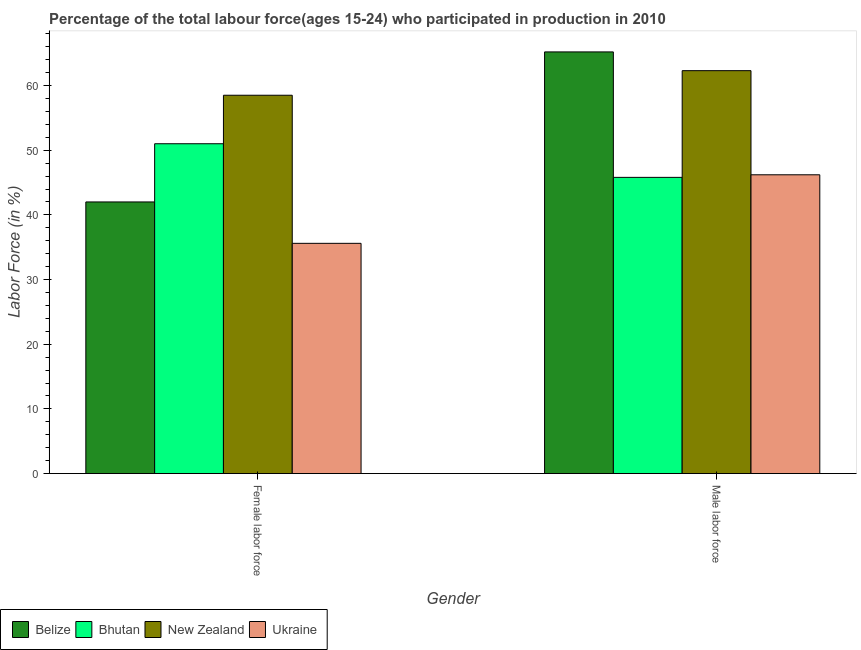How many different coloured bars are there?
Ensure brevity in your answer.  4. Are the number of bars on each tick of the X-axis equal?
Give a very brief answer. Yes. How many bars are there on the 1st tick from the left?
Ensure brevity in your answer.  4. How many bars are there on the 2nd tick from the right?
Keep it short and to the point. 4. What is the label of the 2nd group of bars from the left?
Make the answer very short. Male labor force. What is the percentage of male labour force in New Zealand?
Your response must be concise. 62.3. Across all countries, what is the maximum percentage of male labour force?
Your answer should be compact. 65.2. Across all countries, what is the minimum percentage of male labour force?
Offer a terse response. 45.8. In which country was the percentage of male labour force maximum?
Your answer should be compact. Belize. In which country was the percentage of male labour force minimum?
Provide a short and direct response. Bhutan. What is the total percentage of female labor force in the graph?
Your answer should be very brief. 187.1. What is the difference between the percentage of male labour force in Belize and that in New Zealand?
Offer a very short reply. 2.9. What is the difference between the percentage of male labour force in Bhutan and the percentage of female labor force in New Zealand?
Offer a terse response. -12.7. What is the average percentage of female labor force per country?
Offer a terse response. 46.77. What is the difference between the percentage of male labour force and percentage of female labor force in Belize?
Make the answer very short. 23.2. In how many countries, is the percentage of male labour force greater than 30 %?
Your response must be concise. 4. What is the ratio of the percentage of male labour force in Belize to that in Ukraine?
Make the answer very short. 1.41. What does the 1st bar from the left in Female labor force represents?
Make the answer very short. Belize. What does the 3rd bar from the right in Female labor force represents?
Provide a short and direct response. Bhutan. How many bars are there?
Offer a terse response. 8. Are all the bars in the graph horizontal?
Ensure brevity in your answer.  No. How many countries are there in the graph?
Provide a succinct answer. 4. Does the graph contain grids?
Ensure brevity in your answer.  No. How many legend labels are there?
Offer a terse response. 4. What is the title of the graph?
Provide a short and direct response. Percentage of the total labour force(ages 15-24) who participated in production in 2010. Does "High income" appear as one of the legend labels in the graph?
Provide a short and direct response. No. What is the label or title of the X-axis?
Give a very brief answer. Gender. What is the label or title of the Y-axis?
Your answer should be compact. Labor Force (in %). What is the Labor Force (in %) of New Zealand in Female labor force?
Provide a succinct answer. 58.5. What is the Labor Force (in %) in Ukraine in Female labor force?
Make the answer very short. 35.6. What is the Labor Force (in %) of Belize in Male labor force?
Ensure brevity in your answer.  65.2. What is the Labor Force (in %) in Bhutan in Male labor force?
Make the answer very short. 45.8. What is the Labor Force (in %) in New Zealand in Male labor force?
Offer a terse response. 62.3. What is the Labor Force (in %) in Ukraine in Male labor force?
Keep it short and to the point. 46.2. Across all Gender, what is the maximum Labor Force (in %) in Belize?
Offer a very short reply. 65.2. Across all Gender, what is the maximum Labor Force (in %) of Bhutan?
Ensure brevity in your answer.  51. Across all Gender, what is the maximum Labor Force (in %) in New Zealand?
Your response must be concise. 62.3. Across all Gender, what is the maximum Labor Force (in %) in Ukraine?
Your response must be concise. 46.2. Across all Gender, what is the minimum Labor Force (in %) of Belize?
Ensure brevity in your answer.  42. Across all Gender, what is the minimum Labor Force (in %) in Bhutan?
Give a very brief answer. 45.8. Across all Gender, what is the minimum Labor Force (in %) in New Zealand?
Offer a very short reply. 58.5. Across all Gender, what is the minimum Labor Force (in %) in Ukraine?
Ensure brevity in your answer.  35.6. What is the total Labor Force (in %) of Belize in the graph?
Your answer should be compact. 107.2. What is the total Labor Force (in %) in Bhutan in the graph?
Offer a very short reply. 96.8. What is the total Labor Force (in %) in New Zealand in the graph?
Provide a succinct answer. 120.8. What is the total Labor Force (in %) of Ukraine in the graph?
Your answer should be compact. 81.8. What is the difference between the Labor Force (in %) of Belize in Female labor force and that in Male labor force?
Give a very brief answer. -23.2. What is the difference between the Labor Force (in %) in New Zealand in Female labor force and that in Male labor force?
Provide a short and direct response. -3.8. What is the difference between the Labor Force (in %) of Ukraine in Female labor force and that in Male labor force?
Offer a terse response. -10.6. What is the difference between the Labor Force (in %) in Belize in Female labor force and the Labor Force (in %) in Bhutan in Male labor force?
Offer a very short reply. -3.8. What is the difference between the Labor Force (in %) in Belize in Female labor force and the Labor Force (in %) in New Zealand in Male labor force?
Your answer should be compact. -20.3. What is the difference between the Labor Force (in %) of Bhutan in Female labor force and the Labor Force (in %) of New Zealand in Male labor force?
Ensure brevity in your answer.  -11.3. What is the difference between the Labor Force (in %) in New Zealand in Female labor force and the Labor Force (in %) in Ukraine in Male labor force?
Ensure brevity in your answer.  12.3. What is the average Labor Force (in %) in Belize per Gender?
Make the answer very short. 53.6. What is the average Labor Force (in %) of Bhutan per Gender?
Your response must be concise. 48.4. What is the average Labor Force (in %) in New Zealand per Gender?
Give a very brief answer. 60.4. What is the average Labor Force (in %) of Ukraine per Gender?
Give a very brief answer. 40.9. What is the difference between the Labor Force (in %) in Belize and Labor Force (in %) in New Zealand in Female labor force?
Make the answer very short. -16.5. What is the difference between the Labor Force (in %) in Bhutan and Labor Force (in %) in New Zealand in Female labor force?
Your answer should be very brief. -7.5. What is the difference between the Labor Force (in %) in Bhutan and Labor Force (in %) in Ukraine in Female labor force?
Ensure brevity in your answer.  15.4. What is the difference between the Labor Force (in %) of New Zealand and Labor Force (in %) of Ukraine in Female labor force?
Keep it short and to the point. 22.9. What is the difference between the Labor Force (in %) in Belize and Labor Force (in %) in Ukraine in Male labor force?
Ensure brevity in your answer.  19. What is the difference between the Labor Force (in %) of Bhutan and Labor Force (in %) of New Zealand in Male labor force?
Offer a very short reply. -16.5. What is the difference between the Labor Force (in %) in Bhutan and Labor Force (in %) in Ukraine in Male labor force?
Make the answer very short. -0.4. What is the ratio of the Labor Force (in %) of Belize in Female labor force to that in Male labor force?
Give a very brief answer. 0.64. What is the ratio of the Labor Force (in %) of Bhutan in Female labor force to that in Male labor force?
Make the answer very short. 1.11. What is the ratio of the Labor Force (in %) in New Zealand in Female labor force to that in Male labor force?
Offer a very short reply. 0.94. What is the ratio of the Labor Force (in %) of Ukraine in Female labor force to that in Male labor force?
Provide a short and direct response. 0.77. What is the difference between the highest and the second highest Labor Force (in %) in Belize?
Give a very brief answer. 23.2. What is the difference between the highest and the second highest Labor Force (in %) of Bhutan?
Give a very brief answer. 5.2. What is the difference between the highest and the second highest Labor Force (in %) of Ukraine?
Your answer should be very brief. 10.6. What is the difference between the highest and the lowest Labor Force (in %) of Belize?
Provide a succinct answer. 23.2. What is the difference between the highest and the lowest Labor Force (in %) in Ukraine?
Provide a short and direct response. 10.6. 